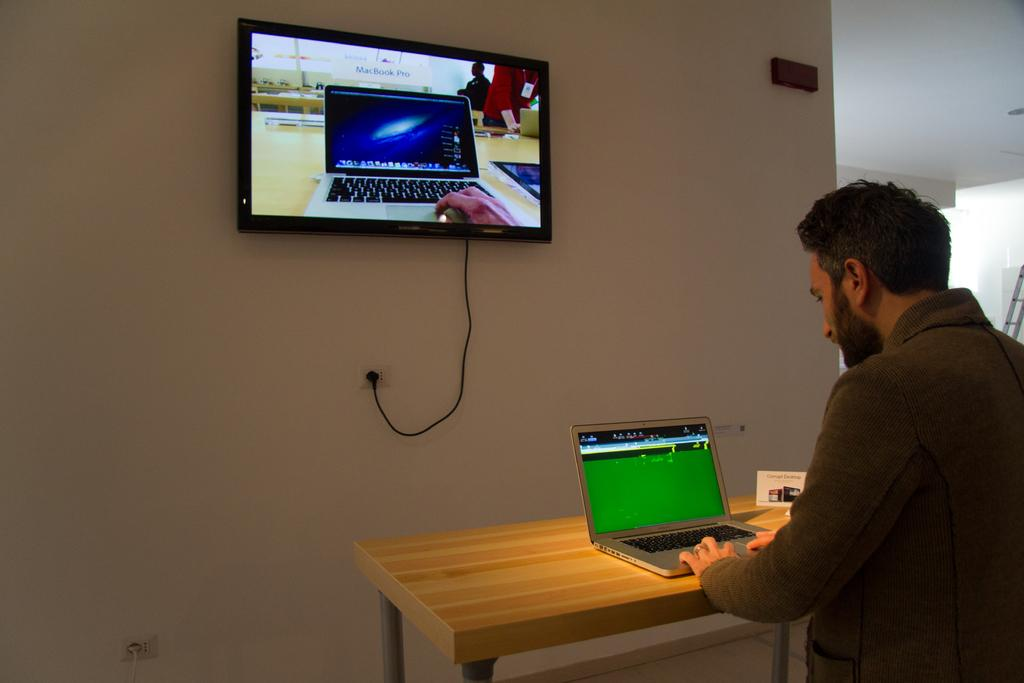What is the person in the image doing? The person is sitting on a chair and using a laptop. Where is the person located in relation to the table? The person is near a table. What can be seen on the wall in the background of the image? There is a television mounted on the wall. What is the general setting of the image? The person is sitting in a room with a table, a chair, and a wall with a television. What type of apparatus is the person using to ride around the room in the image? There is no apparatus for riding in the image; the person is sitting on a chair and using a laptop. Can you hear the bike in the image? There is no bike present in the image, so it cannot be heard. 